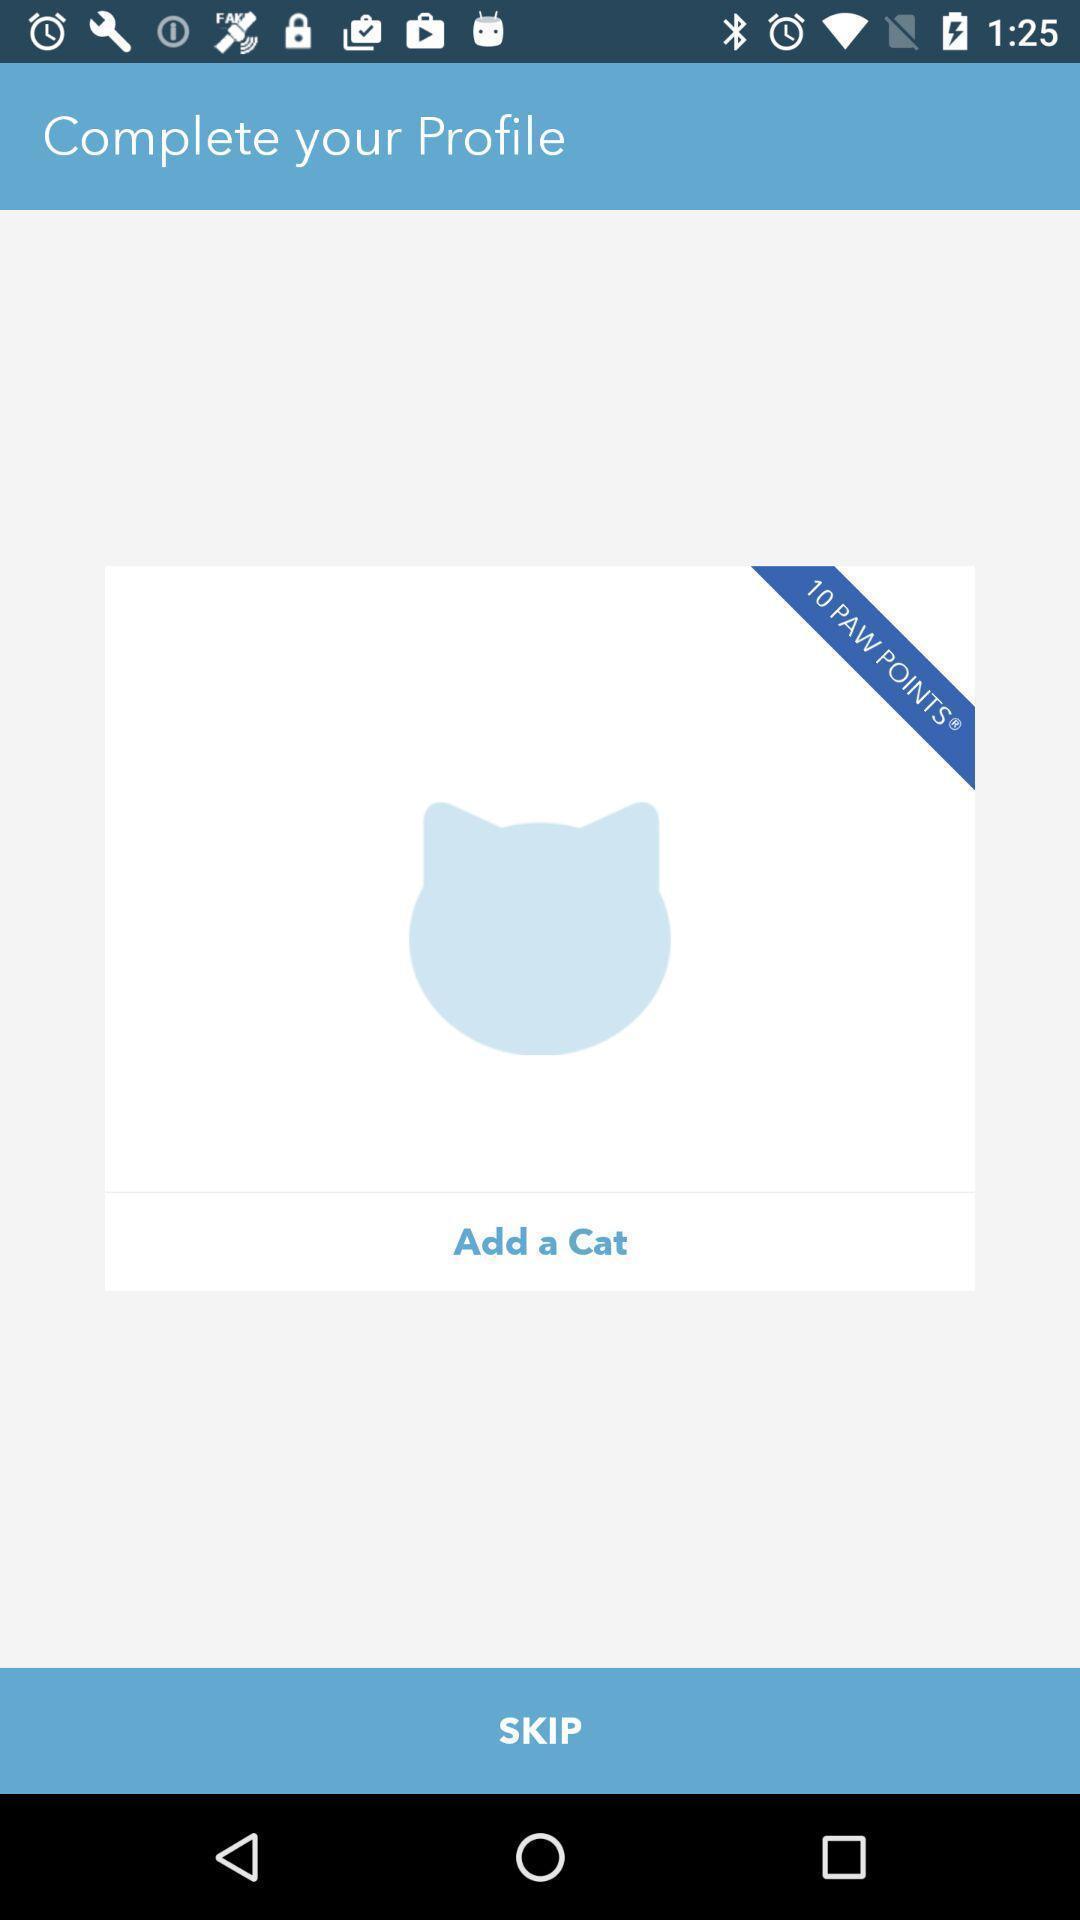Please provide a description for this image. Skip option displaying in this page. 